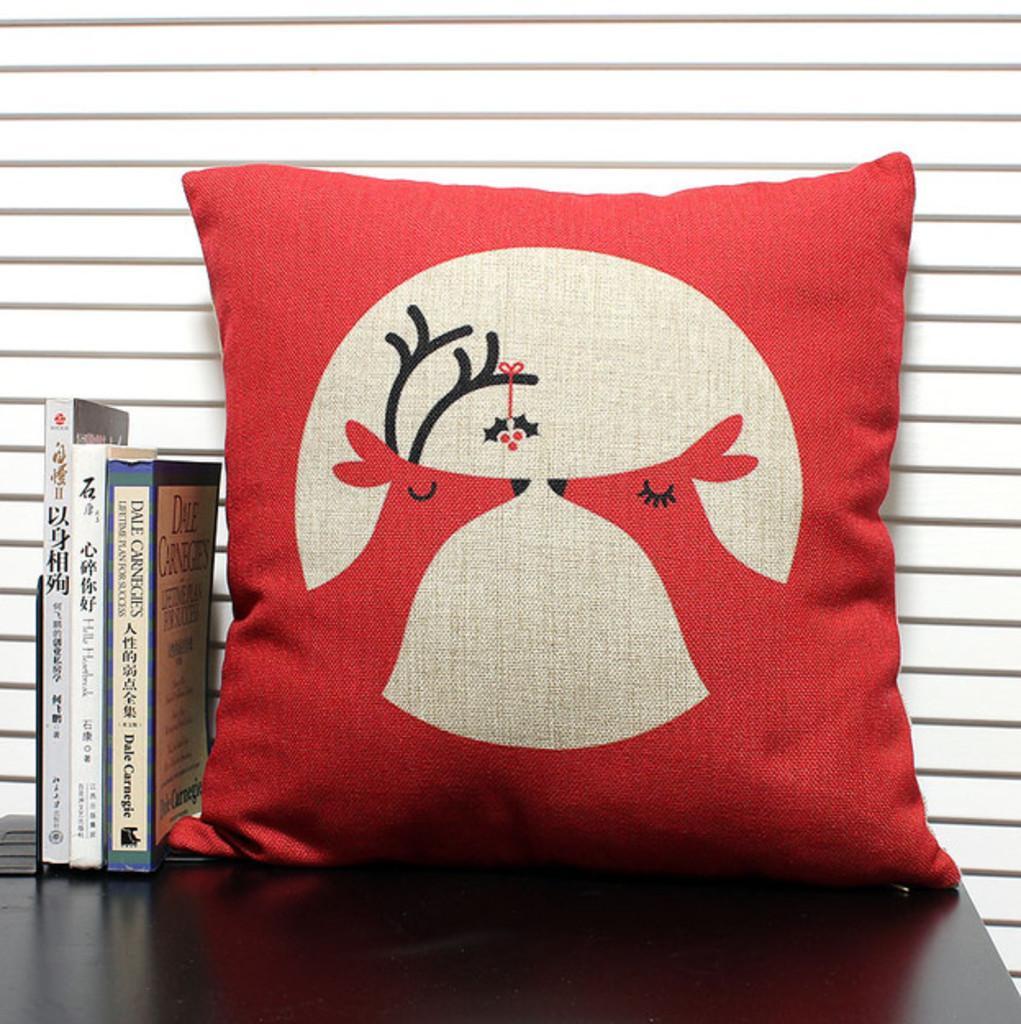In one or two sentences, can you explain what this image depicts? In this image in the center there is one pillow, beside the pillow there are some books. At the bottom there is table, in the background there is a wall. 